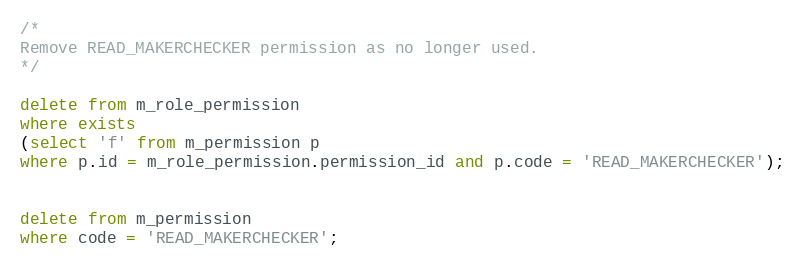<code> <loc_0><loc_0><loc_500><loc_500><_SQL_>/*
Remove READ_MAKERCHECKER permission as no longer used.
*/

delete from m_role_permission
where exists
(select 'f' from m_permission p
where p.id = m_role_permission.permission_id and p.code = 'READ_MAKERCHECKER');


delete from m_permission
where code = 'READ_MAKERCHECKER';

</code> 